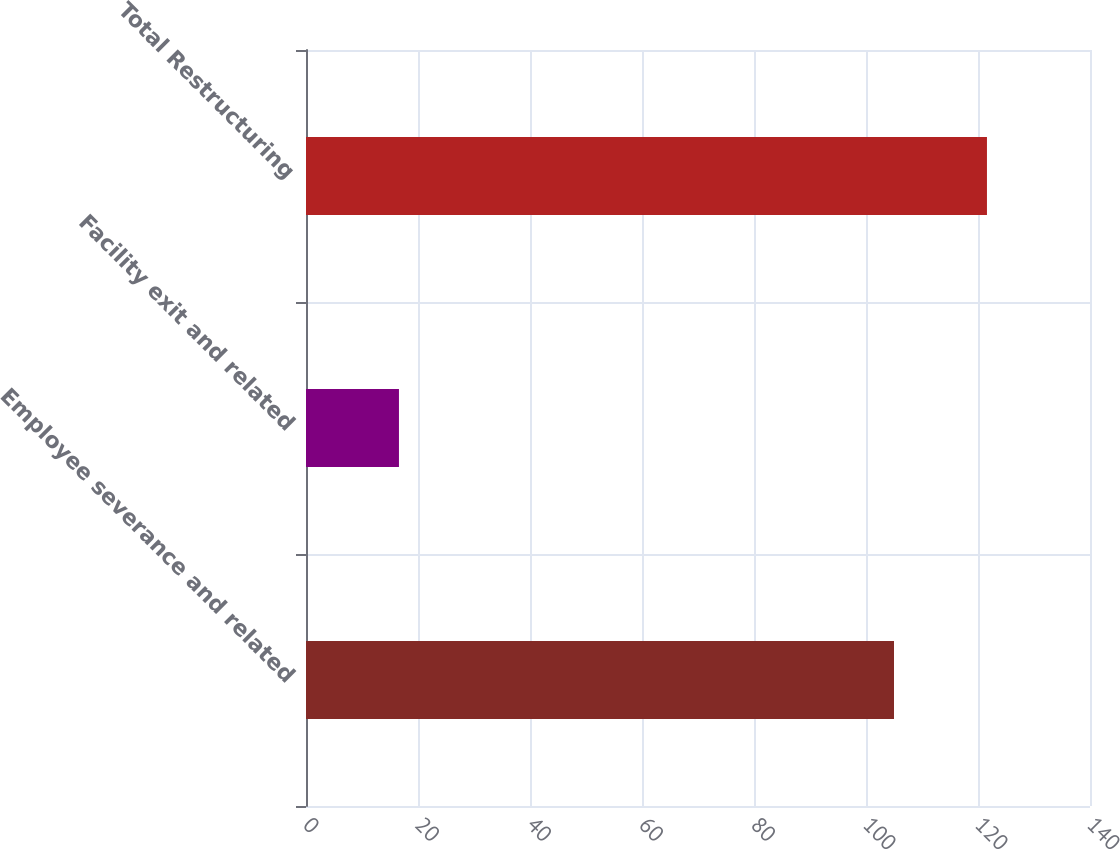Convert chart. <chart><loc_0><loc_0><loc_500><loc_500><bar_chart><fcel>Employee severance and related<fcel>Facility exit and related<fcel>Total Restructuring<nl><fcel>105<fcel>16.6<fcel>121.6<nl></chart> 